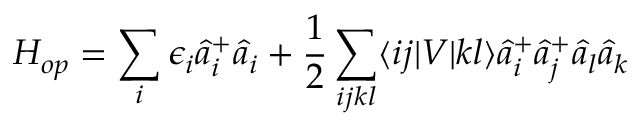Convert formula to latex. <formula><loc_0><loc_0><loc_500><loc_500>H _ { o p } = \sum _ { i } \epsilon _ { i } \hat { a } _ { i } ^ { + } \hat { a } _ { i } + \frac { 1 } { 2 } \sum _ { i j k l } \langle i j | V | k l \rangle \hat { a } _ { i } ^ { + } \hat { a } _ { j } ^ { + } \hat { a } _ { l } \hat { a } _ { k }</formula> 